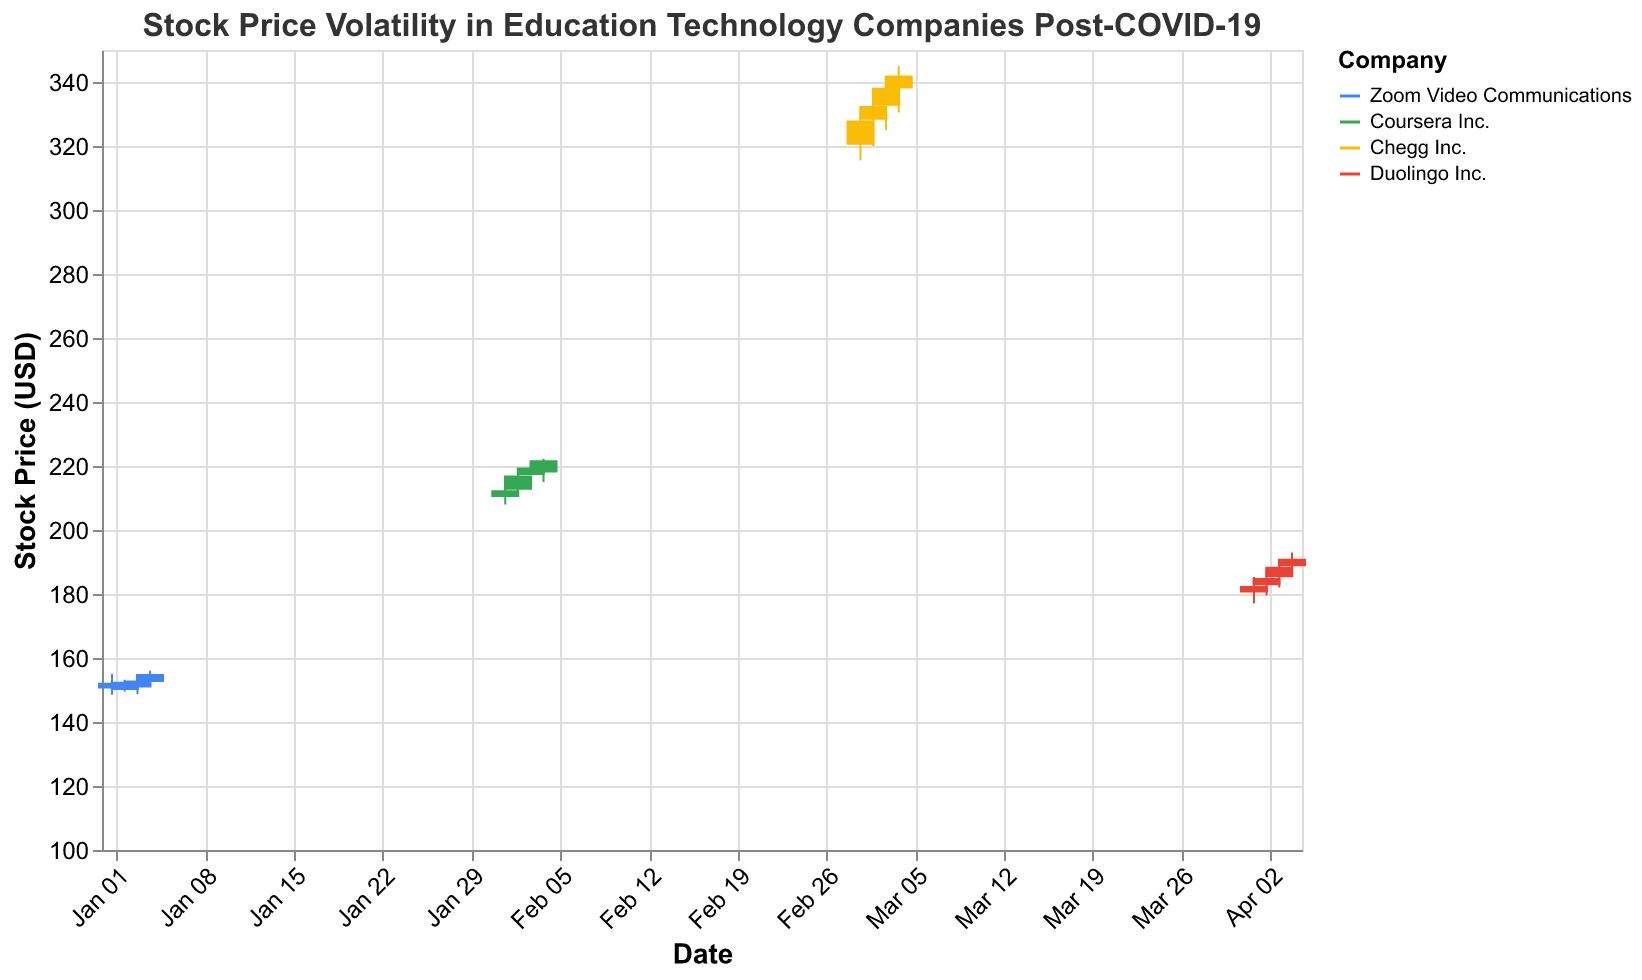What's the title of the figure? The title is displayed at the top of the figure. It reads "Stock Price Volatility in Education Technology Companies Post-COVID-19".
Answer: "Stock Price Volatility in Education Technology Companies Post-COVID-19" Which two companies have the highest high prices on their respective days? Observing the High prices for each company, Chegg Inc. on 2023-03-04 (345.00) and Coursera Inc. on 2023-02-04 (222.30) have the highest recorded High prices.
Answer: Chegg Inc. and Coursera Inc What is the average Close price for Zoom Video Communications in January 2023? Sum the Close prices for Zoom on 2023-01-01 (152.30), 2023-01-02 (150.00), 2023-01-03 (153.00), and 2023-01-04 (155.00) which equal to 610.30, then divide by the number of days (4). The average is 610.30/4 = 152.575.
Answer: 152.575 Which company has the highest volume of trades? Checking the volume column, Chegg Inc. on 2023-03-01 (3,300,000) has the highest number of trades.
Answer: Chegg Inc What was the lowest low price recorded for any company, and which company experienced it? The lowest value in the Low column is 148.50 by Zoom Video Communications on 2023-01-01.
Answer: 148.50 by Zoom Video Communications Which company showed the highest volatility within a single day in the given data? Volatility can be observed through the difference between the High and Low prices. Chegg Inc. on 2023-03-03 had the highest volatility, with a High of 340.50 and a Low of 325, making the difference 15.50.
Answer: Chegg Inc Comparing March and April, which company’s stock price closed higher on the last day of the month? Checking the Close prices for the last days of March and April, Chegg Inc. (342.00 on 2023-03-04) closed higher than Duolingo Inc. (191.00 on 2023-04-04).
Answer: Chegg Inc What trend can be observed in the Close prices of Coursera Inc. from February 1 to February 4? Observing the Close prices from February 1 (212.40), February 2 (217.00), February 3 (219.50), and February 4 (221.80), there is a clear upward trend.
Answer: Upward trend Which company's stock had the most significant increase in Close price from one day to the next? Looking for the largest difference between consecutive Close prices, Coursera Inc. from February 1 (212.40) to February 2 (217.00) had an increase of 4.60, the most significant increase observed.
Answer: Coursera Inc On which date did Duolingo Inc.'s stock close at its highest value, and what was the price? Duolingo Inc.'s highest Close price was on 2023-04-04, with a price of 191.00.
Answer: 2023-04-04, 191.00 